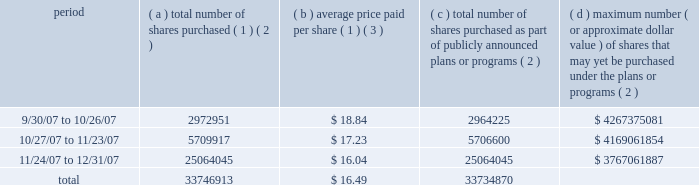Part ii item 5 : market for registrant 2019s common equity , related stockholder matters and issuer purchases of equity securities motorola 2019s common stock is listed on the new york and chicago stock exchanges .
The number of stockholders of record of motorola common stock on january 31 , 2008 was 79907 .
Information regarding securities authorized for issuance under equity compensation plans is incorporated by reference to the information under the caption 201cequity compensation plan information 201d of motorola 2019s proxy statement for the 2008 annual meeting of stockholders .
The remainder of the response to this item incorporates by reference note 16 , 201cquarterly and other financial data ( unaudited ) 201d of the notes to consolidated financial statements appearing under 201citem 8 : financial statements and supplementary data 201d .
The table provides information with respect to acquisitions by the company of shares of its common stock during the quarter ended december 31 , 2007 .
Issuer purchases of equity securities period ( a ) total number of shares purchased ( 1 ) ( 2 ) ( b ) average price paid per share ( 1 ) ( 3 ) ( c ) total number of shares purchased as part of publicly announced plans or programs ( 2 ) ( d ) maximum number ( or approximate dollar value ) of shares that may yet be purchased under the plans or programs ( 2 ) .
( 1 ) in addition to purchases under the 2006 stock repurchase program ( as defined below ) , included in this column are transactions under the company 2019s equity compensation plans involving the delivery to the company of 12043 shares of motorola common stock to satisfy tax withholding obligations in connection with the vesting of restricted stock granted to company employees .
( 2 ) through actions taken on july 24 , 2006 and march 21 , 2007 , the board of directors has authorized the company to repurchase an aggregate amount of up to $ 7.5 billion of its outstanding shares of common stock over a period ending in june 2009 , subject to market conditions ( the 201c2006 stock repurchase program 201d ) .
( 3 ) average price paid per share of common stock repurchased under the 2006 stock repurchase program is execution price , excluding commissions paid to brokers. .
In 2007 what was the percent of the total number of shares purchased after 11/24/07? 
Computations: (25064045 / 33746913)
Answer: 0.74271. Part ii item 5 : market for registrant 2019s common equity , related stockholder matters and issuer purchases of equity securities motorola 2019s common stock is listed on the new york and chicago stock exchanges .
The number of stockholders of record of motorola common stock on january 31 , 2008 was 79907 .
Information regarding securities authorized for issuance under equity compensation plans is incorporated by reference to the information under the caption 201cequity compensation plan information 201d of motorola 2019s proxy statement for the 2008 annual meeting of stockholders .
The remainder of the response to this item incorporates by reference note 16 , 201cquarterly and other financial data ( unaudited ) 201d of the notes to consolidated financial statements appearing under 201citem 8 : financial statements and supplementary data 201d .
The table provides information with respect to acquisitions by the company of shares of its common stock during the quarter ended december 31 , 2007 .
Issuer purchases of equity securities period ( a ) total number of shares purchased ( 1 ) ( 2 ) ( b ) average price paid per share ( 1 ) ( 3 ) ( c ) total number of shares purchased as part of publicly announced plans or programs ( 2 ) ( d ) maximum number ( or approximate dollar value ) of shares that may yet be purchased under the plans or programs ( 2 ) .
( 1 ) in addition to purchases under the 2006 stock repurchase program ( as defined below ) , included in this column are transactions under the company 2019s equity compensation plans involving the delivery to the company of 12043 shares of motorola common stock to satisfy tax withholding obligations in connection with the vesting of restricted stock granted to company employees .
( 2 ) through actions taken on july 24 , 2006 and march 21 , 2007 , the board of directors has authorized the company to repurchase an aggregate amount of up to $ 7.5 billion of its outstanding shares of common stock over a period ending in june 2009 , subject to market conditions ( the 201c2006 stock repurchase program 201d ) .
( 3 ) average price paid per share of common stock repurchased under the 2006 stock repurchase program is execution price , excluding commissions paid to brokers. .
What is the estimated value , in dollars , of the total number of shares purchased between 9/30/07 and 10/26/07? 
Rationale: estimated amount since price per share is average
Computations: (18.84 * 2972951)
Answer: 56010396.84. Part ii item 5 : market for registrant 2019s common equity , related stockholder matters and issuer purchases of equity securities motorola 2019s common stock is listed on the new york and chicago stock exchanges .
The number of stockholders of record of motorola common stock on january 31 , 2008 was 79907 .
Information regarding securities authorized for issuance under equity compensation plans is incorporated by reference to the information under the caption 201cequity compensation plan information 201d of motorola 2019s proxy statement for the 2008 annual meeting of stockholders .
The remainder of the response to this item incorporates by reference note 16 , 201cquarterly and other financial data ( unaudited ) 201d of the notes to consolidated financial statements appearing under 201citem 8 : financial statements and supplementary data 201d .
The table provides information with respect to acquisitions by the company of shares of its common stock during the quarter ended december 31 , 2007 .
Issuer purchases of equity securities period ( a ) total number of shares purchased ( 1 ) ( 2 ) ( b ) average price paid per share ( 1 ) ( 3 ) ( c ) total number of shares purchased as part of publicly announced plans or programs ( 2 ) ( d ) maximum number ( or approximate dollar value ) of shares that may yet be purchased under the plans or programs ( 2 ) .
( 1 ) in addition to purchases under the 2006 stock repurchase program ( as defined below ) , included in this column are transactions under the company 2019s equity compensation plans involving the delivery to the company of 12043 shares of motorola common stock to satisfy tax withholding obligations in connection with the vesting of restricted stock granted to company employees .
( 2 ) through actions taken on july 24 , 2006 and march 21 , 2007 , the board of directors has authorized the company to repurchase an aggregate amount of up to $ 7.5 billion of its outstanding shares of common stock over a period ending in june 2009 , subject to market conditions ( the 201c2006 stock repurchase program 201d ) .
( 3 ) average price paid per share of common stock repurchased under the 2006 stock repurchase program is execution price , excluding commissions paid to brokers. .
How many shares can still be bought between 9/30/07 and 10/26/07 if the average price remains the same? 
Computations: (4267375081 / 18.84)
Answer: 226506108.33333. 